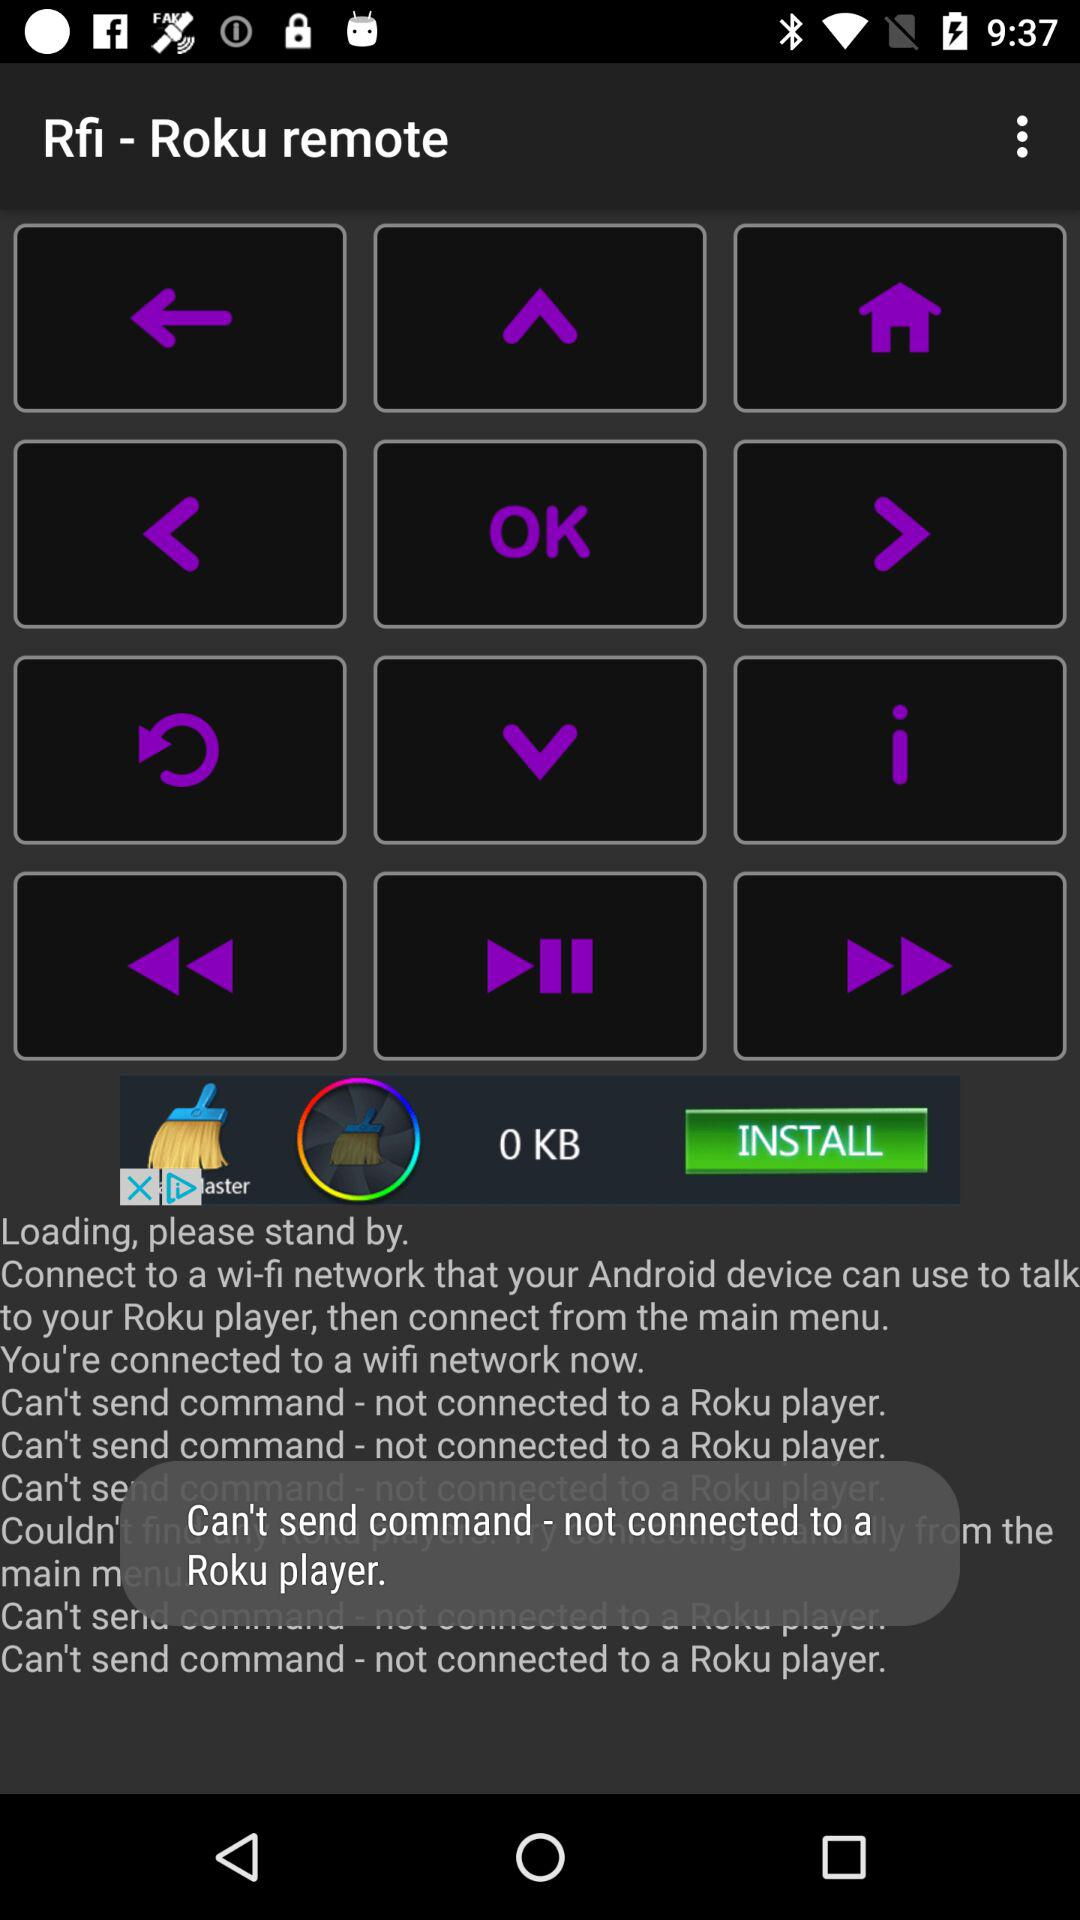Which button is selected?
When the provided information is insufficient, respond with <no answer>. <no answer> 